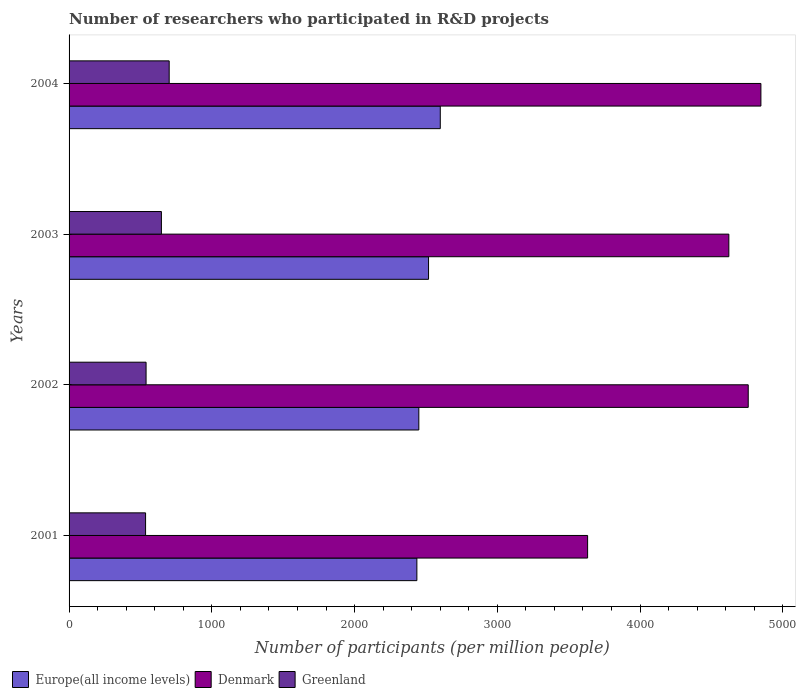Are the number of bars on each tick of the Y-axis equal?
Your answer should be compact. Yes. How many bars are there on the 3rd tick from the bottom?
Give a very brief answer. 3. In how many cases, is the number of bars for a given year not equal to the number of legend labels?
Make the answer very short. 0. What is the number of researchers who participated in R&D projects in Denmark in 2001?
Offer a terse response. 3632.88. Across all years, what is the maximum number of researchers who participated in R&D projects in Greenland?
Give a very brief answer. 701.46. Across all years, what is the minimum number of researchers who participated in R&D projects in Denmark?
Provide a short and direct response. 3632.88. In which year was the number of researchers who participated in R&D projects in Greenland minimum?
Ensure brevity in your answer.  2001. What is the total number of researchers who participated in R&D projects in Denmark in the graph?
Offer a very short reply. 1.79e+04. What is the difference between the number of researchers who participated in R&D projects in Greenland in 2002 and that in 2004?
Give a very brief answer. -161.97. What is the difference between the number of researchers who participated in R&D projects in Europe(all income levels) in 2001 and the number of researchers who participated in R&D projects in Denmark in 2002?
Your answer should be very brief. -2321.41. What is the average number of researchers who participated in R&D projects in Europe(all income levels) per year?
Give a very brief answer. 2501.57. In the year 2003, what is the difference between the number of researchers who participated in R&D projects in Greenland and number of researchers who participated in R&D projects in Europe(all income levels)?
Ensure brevity in your answer.  -1871.53. What is the ratio of the number of researchers who participated in R&D projects in Denmark in 2002 to that in 2003?
Provide a succinct answer. 1.03. Is the number of researchers who participated in R&D projects in Greenland in 2002 less than that in 2004?
Your response must be concise. Yes. Is the difference between the number of researchers who participated in R&D projects in Greenland in 2001 and 2004 greater than the difference between the number of researchers who participated in R&D projects in Europe(all income levels) in 2001 and 2004?
Provide a succinct answer. No. What is the difference between the highest and the second highest number of researchers who participated in R&D projects in Greenland?
Offer a very short reply. 54.56. What is the difference between the highest and the lowest number of researchers who participated in R&D projects in Europe(all income levels)?
Offer a very short reply. 163.95. In how many years, is the number of researchers who participated in R&D projects in Greenland greater than the average number of researchers who participated in R&D projects in Greenland taken over all years?
Provide a short and direct response. 2. Is the sum of the number of researchers who participated in R&D projects in Europe(all income levels) in 2003 and 2004 greater than the maximum number of researchers who participated in R&D projects in Greenland across all years?
Give a very brief answer. Yes. What does the 1st bar from the top in 2002 represents?
Provide a short and direct response. Greenland. What does the 2nd bar from the bottom in 2001 represents?
Your answer should be compact. Denmark. Are all the bars in the graph horizontal?
Provide a succinct answer. Yes. What is the difference between two consecutive major ticks on the X-axis?
Ensure brevity in your answer.  1000. Does the graph contain grids?
Your answer should be very brief. No. Where does the legend appear in the graph?
Offer a terse response. Bottom left. What is the title of the graph?
Ensure brevity in your answer.  Number of researchers who participated in R&D projects. What is the label or title of the X-axis?
Offer a terse response. Number of participants (per million people). What is the label or title of the Y-axis?
Provide a succinct answer. Years. What is the Number of participants (per million people) in Europe(all income levels) in 2001?
Give a very brief answer. 2436.76. What is the Number of participants (per million people) of Denmark in 2001?
Your response must be concise. 3632.88. What is the Number of participants (per million people) of Greenland in 2001?
Make the answer very short. 536.06. What is the Number of participants (per million people) of Europe(all income levels) in 2002?
Ensure brevity in your answer.  2450.36. What is the Number of participants (per million people) in Denmark in 2002?
Your answer should be compact. 4758.17. What is the Number of participants (per million people) of Greenland in 2002?
Ensure brevity in your answer.  539.5. What is the Number of participants (per million people) of Europe(all income levels) in 2003?
Give a very brief answer. 2518.44. What is the Number of participants (per million people) of Denmark in 2003?
Offer a terse response. 4622.37. What is the Number of participants (per million people) in Greenland in 2003?
Your response must be concise. 646.9. What is the Number of participants (per million people) of Europe(all income levels) in 2004?
Offer a terse response. 2600.71. What is the Number of participants (per million people) of Denmark in 2004?
Offer a very short reply. 4846.95. What is the Number of participants (per million people) of Greenland in 2004?
Offer a terse response. 701.46. Across all years, what is the maximum Number of participants (per million people) in Europe(all income levels)?
Make the answer very short. 2600.71. Across all years, what is the maximum Number of participants (per million people) in Denmark?
Your answer should be compact. 4846.95. Across all years, what is the maximum Number of participants (per million people) of Greenland?
Your response must be concise. 701.46. Across all years, what is the minimum Number of participants (per million people) of Europe(all income levels)?
Your response must be concise. 2436.76. Across all years, what is the minimum Number of participants (per million people) in Denmark?
Give a very brief answer. 3632.88. Across all years, what is the minimum Number of participants (per million people) of Greenland?
Your answer should be compact. 536.06. What is the total Number of participants (per million people) in Europe(all income levels) in the graph?
Offer a very short reply. 1.00e+04. What is the total Number of participants (per million people) of Denmark in the graph?
Provide a succinct answer. 1.79e+04. What is the total Number of participants (per million people) in Greenland in the graph?
Make the answer very short. 2423.92. What is the difference between the Number of participants (per million people) of Europe(all income levels) in 2001 and that in 2002?
Provide a short and direct response. -13.6. What is the difference between the Number of participants (per million people) of Denmark in 2001 and that in 2002?
Offer a terse response. -1125.29. What is the difference between the Number of participants (per million people) in Greenland in 2001 and that in 2002?
Ensure brevity in your answer.  -3.44. What is the difference between the Number of participants (per million people) of Europe(all income levels) in 2001 and that in 2003?
Ensure brevity in your answer.  -81.67. What is the difference between the Number of participants (per million people) in Denmark in 2001 and that in 2003?
Ensure brevity in your answer.  -989.49. What is the difference between the Number of participants (per million people) of Greenland in 2001 and that in 2003?
Offer a terse response. -110.84. What is the difference between the Number of participants (per million people) in Europe(all income levels) in 2001 and that in 2004?
Make the answer very short. -163.95. What is the difference between the Number of participants (per million people) of Denmark in 2001 and that in 2004?
Provide a succinct answer. -1214.07. What is the difference between the Number of participants (per million people) in Greenland in 2001 and that in 2004?
Your answer should be compact. -165.4. What is the difference between the Number of participants (per million people) in Europe(all income levels) in 2002 and that in 2003?
Your answer should be compact. -68.08. What is the difference between the Number of participants (per million people) in Denmark in 2002 and that in 2003?
Keep it short and to the point. 135.8. What is the difference between the Number of participants (per million people) of Greenland in 2002 and that in 2003?
Give a very brief answer. -107.4. What is the difference between the Number of participants (per million people) of Europe(all income levels) in 2002 and that in 2004?
Your response must be concise. -150.35. What is the difference between the Number of participants (per million people) of Denmark in 2002 and that in 2004?
Keep it short and to the point. -88.77. What is the difference between the Number of participants (per million people) in Greenland in 2002 and that in 2004?
Ensure brevity in your answer.  -161.97. What is the difference between the Number of participants (per million people) in Europe(all income levels) in 2003 and that in 2004?
Provide a short and direct response. -82.28. What is the difference between the Number of participants (per million people) in Denmark in 2003 and that in 2004?
Make the answer very short. -224.58. What is the difference between the Number of participants (per million people) of Greenland in 2003 and that in 2004?
Offer a terse response. -54.56. What is the difference between the Number of participants (per million people) in Europe(all income levels) in 2001 and the Number of participants (per million people) in Denmark in 2002?
Offer a terse response. -2321.41. What is the difference between the Number of participants (per million people) in Europe(all income levels) in 2001 and the Number of participants (per million people) in Greenland in 2002?
Provide a succinct answer. 1897.26. What is the difference between the Number of participants (per million people) in Denmark in 2001 and the Number of participants (per million people) in Greenland in 2002?
Your answer should be compact. 3093.38. What is the difference between the Number of participants (per million people) in Europe(all income levels) in 2001 and the Number of participants (per million people) in Denmark in 2003?
Provide a short and direct response. -2185.61. What is the difference between the Number of participants (per million people) of Europe(all income levels) in 2001 and the Number of participants (per million people) of Greenland in 2003?
Offer a terse response. 1789.86. What is the difference between the Number of participants (per million people) of Denmark in 2001 and the Number of participants (per million people) of Greenland in 2003?
Provide a short and direct response. 2985.98. What is the difference between the Number of participants (per million people) of Europe(all income levels) in 2001 and the Number of participants (per million people) of Denmark in 2004?
Provide a short and direct response. -2410.18. What is the difference between the Number of participants (per million people) in Europe(all income levels) in 2001 and the Number of participants (per million people) in Greenland in 2004?
Offer a terse response. 1735.3. What is the difference between the Number of participants (per million people) in Denmark in 2001 and the Number of participants (per million people) in Greenland in 2004?
Offer a terse response. 2931.42. What is the difference between the Number of participants (per million people) of Europe(all income levels) in 2002 and the Number of participants (per million people) of Denmark in 2003?
Give a very brief answer. -2172.01. What is the difference between the Number of participants (per million people) of Europe(all income levels) in 2002 and the Number of participants (per million people) of Greenland in 2003?
Your response must be concise. 1803.46. What is the difference between the Number of participants (per million people) in Denmark in 2002 and the Number of participants (per million people) in Greenland in 2003?
Provide a succinct answer. 4111.27. What is the difference between the Number of participants (per million people) of Europe(all income levels) in 2002 and the Number of participants (per million people) of Denmark in 2004?
Ensure brevity in your answer.  -2396.59. What is the difference between the Number of participants (per million people) of Europe(all income levels) in 2002 and the Number of participants (per million people) of Greenland in 2004?
Offer a very short reply. 1748.9. What is the difference between the Number of participants (per million people) in Denmark in 2002 and the Number of participants (per million people) in Greenland in 2004?
Provide a short and direct response. 4056.71. What is the difference between the Number of participants (per million people) of Europe(all income levels) in 2003 and the Number of participants (per million people) of Denmark in 2004?
Your response must be concise. -2328.51. What is the difference between the Number of participants (per million people) of Europe(all income levels) in 2003 and the Number of participants (per million people) of Greenland in 2004?
Give a very brief answer. 1816.97. What is the difference between the Number of participants (per million people) of Denmark in 2003 and the Number of participants (per million people) of Greenland in 2004?
Keep it short and to the point. 3920.9. What is the average Number of participants (per million people) in Europe(all income levels) per year?
Offer a very short reply. 2501.57. What is the average Number of participants (per million people) in Denmark per year?
Your response must be concise. 4465.09. What is the average Number of participants (per million people) in Greenland per year?
Your answer should be very brief. 605.98. In the year 2001, what is the difference between the Number of participants (per million people) of Europe(all income levels) and Number of participants (per million people) of Denmark?
Ensure brevity in your answer.  -1196.12. In the year 2001, what is the difference between the Number of participants (per million people) in Europe(all income levels) and Number of participants (per million people) in Greenland?
Provide a short and direct response. 1900.7. In the year 2001, what is the difference between the Number of participants (per million people) of Denmark and Number of participants (per million people) of Greenland?
Provide a short and direct response. 3096.82. In the year 2002, what is the difference between the Number of participants (per million people) in Europe(all income levels) and Number of participants (per million people) in Denmark?
Your response must be concise. -2307.81. In the year 2002, what is the difference between the Number of participants (per million people) of Europe(all income levels) and Number of participants (per million people) of Greenland?
Give a very brief answer. 1910.86. In the year 2002, what is the difference between the Number of participants (per million people) of Denmark and Number of participants (per million people) of Greenland?
Keep it short and to the point. 4218.67. In the year 2003, what is the difference between the Number of participants (per million people) of Europe(all income levels) and Number of participants (per million people) of Denmark?
Offer a terse response. -2103.93. In the year 2003, what is the difference between the Number of participants (per million people) of Europe(all income levels) and Number of participants (per million people) of Greenland?
Your answer should be compact. 1871.53. In the year 2003, what is the difference between the Number of participants (per million people) of Denmark and Number of participants (per million people) of Greenland?
Make the answer very short. 3975.47. In the year 2004, what is the difference between the Number of participants (per million people) in Europe(all income levels) and Number of participants (per million people) in Denmark?
Make the answer very short. -2246.24. In the year 2004, what is the difference between the Number of participants (per million people) in Europe(all income levels) and Number of participants (per million people) in Greenland?
Make the answer very short. 1899.25. In the year 2004, what is the difference between the Number of participants (per million people) in Denmark and Number of participants (per million people) in Greenland?
Give a very brief answer. 4145.48. What is the ratio of the Number of participants (per million people) in Denmark in 2001 to that in 2002?
Keep it short and to the point. 0.76. What is the ratio of the Number of participants (per million people) of Europe(all income levels) in 2001 to that in 2003?
Make the answer very short. 0.97. What is the ratio of the Number of participants (per million people) in Denmark in 2001 to that in 2003?
Ensure brevity in your answer.  0.79. What is the ratio of the Number of participants (per million people) in Greenland in 2001 to that in 2003?
Your answer should be very brief. 0.83. What is the ratio of the Number of participants (per million people) in Europe(all income levels) in 2001 to that in 2004?
Your response must be concise. 0.94. What is the ratio of the Number of participants (per million people) of Denmark in 2001 to that in 2004?
Ensure brevity in your answer.  0.75. What is the ratio of the Number of participants (per million people) in Greenland in 2001 to that in 2004?
Provide a succinct answer. 0.76. What is the ratio of the Number of participants (per million people) of Europe(all income levels) in 2002 to that in 2003?
Offer a very short reply. 0.97. What is the ratio of the Number of participants (per million people) of Denmark in 2002 to that in 2003?
Provide a short and direct response. 1.03. What is the ratio of the Number of participants (per million people) of Greenland in 2002 to that in 2003?
Your answer should be compact. 0.83. What is the ratio of the Number of participants (per million people) of Europe(all income levels) in 2002 to that in 2004?
Offer a terse response. 0.94. What is the ratio of the Number of participants (per million people) of Denmark in 2002 to that in 2004?
Provide a short and direct response. 0.98. What is the ratio of the Number of participants (per million people) of Greenland in 2002 to that in 2004?
Your answer should be compact. 0.77. What is the ratio of the Number of participants (per million people) of Europe(all income levels) in 2003 to that in 2004?
Give a very brief answer. 0.97. What is the ratio of the Number of participants (per million people) in Denmark in 2003 to that in 2004?
Provide a short and direct response. 0.95. What is the ratio of the Number of participants (per million people) of Greenland in 2003 to that in 2004?
Offer a very short reply. 0.92. What is the difference between the highest and the second highest Number of participants (per million people) of Europe(all income levels)?
Keep it short and to the point. 82.28. What is the difference between the highest and the second highest Number of participants (per million people) of Denmark?
Offer a very short reply. 88.77. What is the difference between the highest and the second highest Number of participants (per million people) in Greenland?
Give a very brief answer. 54.56. What is the difference between the highest and the lowest Number of participants (per million people) in Europe(all income levels)?
Keep it short and to the point. 163.95. What is the difference between the highest and the lowest Number of participants (per million people) of Denmark?
Provide a succinct answer. 1214.07. What is the difference between the highest and the lowest Number of participants (per million people) in Greenland?
Provide a succinct answer. 165.4. 